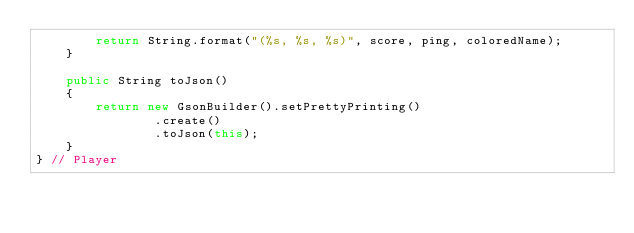<code> <loc_0><loc_0><loc_500><loc_500><_Java_>        return String.format("(%s, %s, %s)", score, ping, coloredName);
    }

    public String toJson()
    {
        return new GsonBuilder().setPrettyPrinting()
                .create()
                .toJson(this);
    }
} // Player</code> 